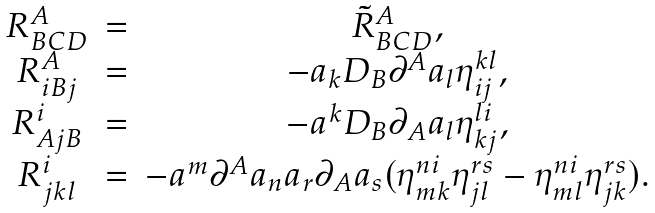<formula> <loc_0><loc_0><loc_500><loc_500>\begin{array} { c c c } { { R _ { B C D } ^ { A } } } & { = } & { { \tilde { R } _ { B C D } ^ { A } , } } \\ { { R _ { i B j } ^ { A } } } & { = } & { { - a _ { k } D _ { B } \partial ^ { A } a _ { l } \eta _ { i j } ^ { k l } , } } \\ { { R _ { A j B } ^ { i } } } & { = } & { { - a ^ { k } D _ { B } \partial _ { A } a _ { l } \eta _ { k j } ^ { l i } , } } \\ { { R _ { j k l } ^ { i } } } & { = } & { { - a ^ { m } \partial ^ { A } a _ { n } a _ { r } \partial _ { A } a _ { s } ( \eta _ { m k } ^ { n i } \eta _ { j l } ^ { r s } - \eta _ { m l } ^ { n i } \eta _ { j k } ^ { r s } ) . } } \end{array}</formula> 